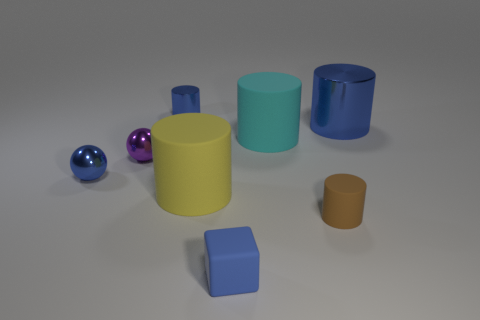There is a metallic cylinder that is on the left side of the small rubber cube; what is its size?
Your answer should be very brief. Small. What number of tiny brown objects are the same shape as the yellow object?
Keep it short and to the point. 1. There is a large cyan object that is the same material as the small blue cube; what shape is it?
Ensure brevity in your answer.  Cylinder. What number of gray objects are tiny balls or small shiny cylinders?
Make the answer very short. 0. Are there any things right of the small matte cylinder?
Your answer should be compact. Yes. Does the shiny object on the right side of the big cyan matte cylinder have the same shape as the small rubber thing that is behind the blue rubber thing?
Keep it short and to the point. Yes. What is the material of the big cyan object that is the same shape as the big yellow rubber thing?
Give a very brief answer. Rubber. What number of cylinders are either big gray matte things or large blue shiny things?
Your answer should be compact. 1. How many other large blue things are made of the same material as the big blue object?
Your response must be concise. 0. Is the material of the sphere that is on the right side of the small blue sphere the same as the big object that is in front of the cyan cylinder?
Offer a very short reply. No. 